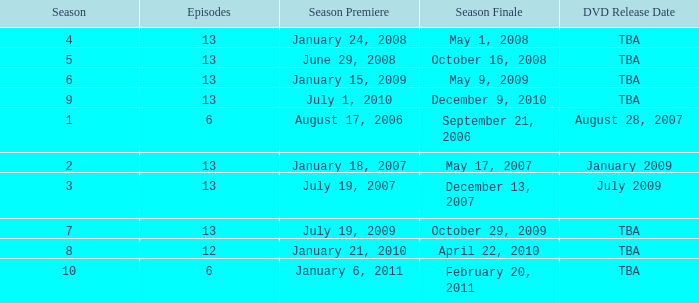Which season had fewer than 13 episodes and aired its season finale on February 20, 2011? 1.0. 